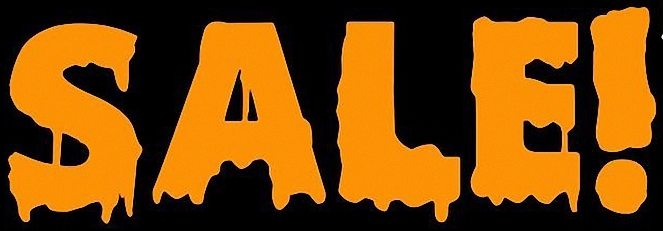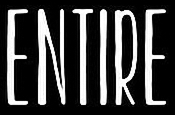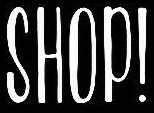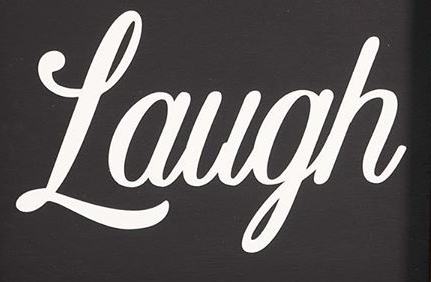Read the text content from these images in order, separated by a semicolon. SALE!; ENTIRE; SHOP!; Laugh 